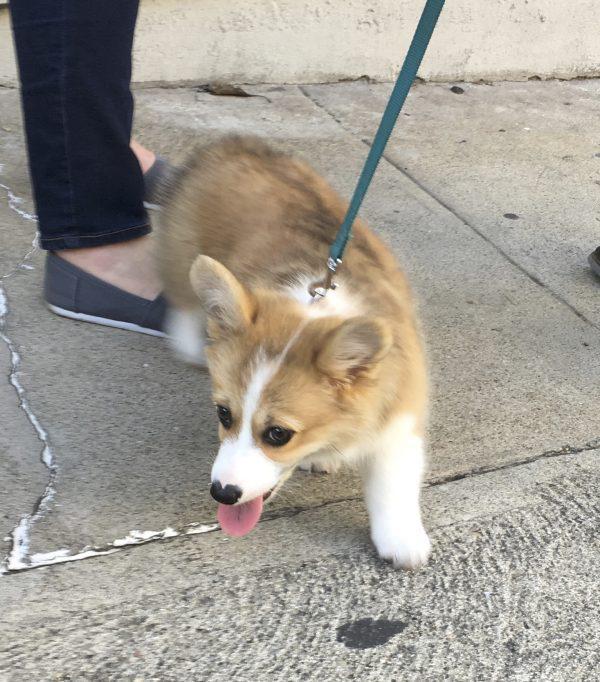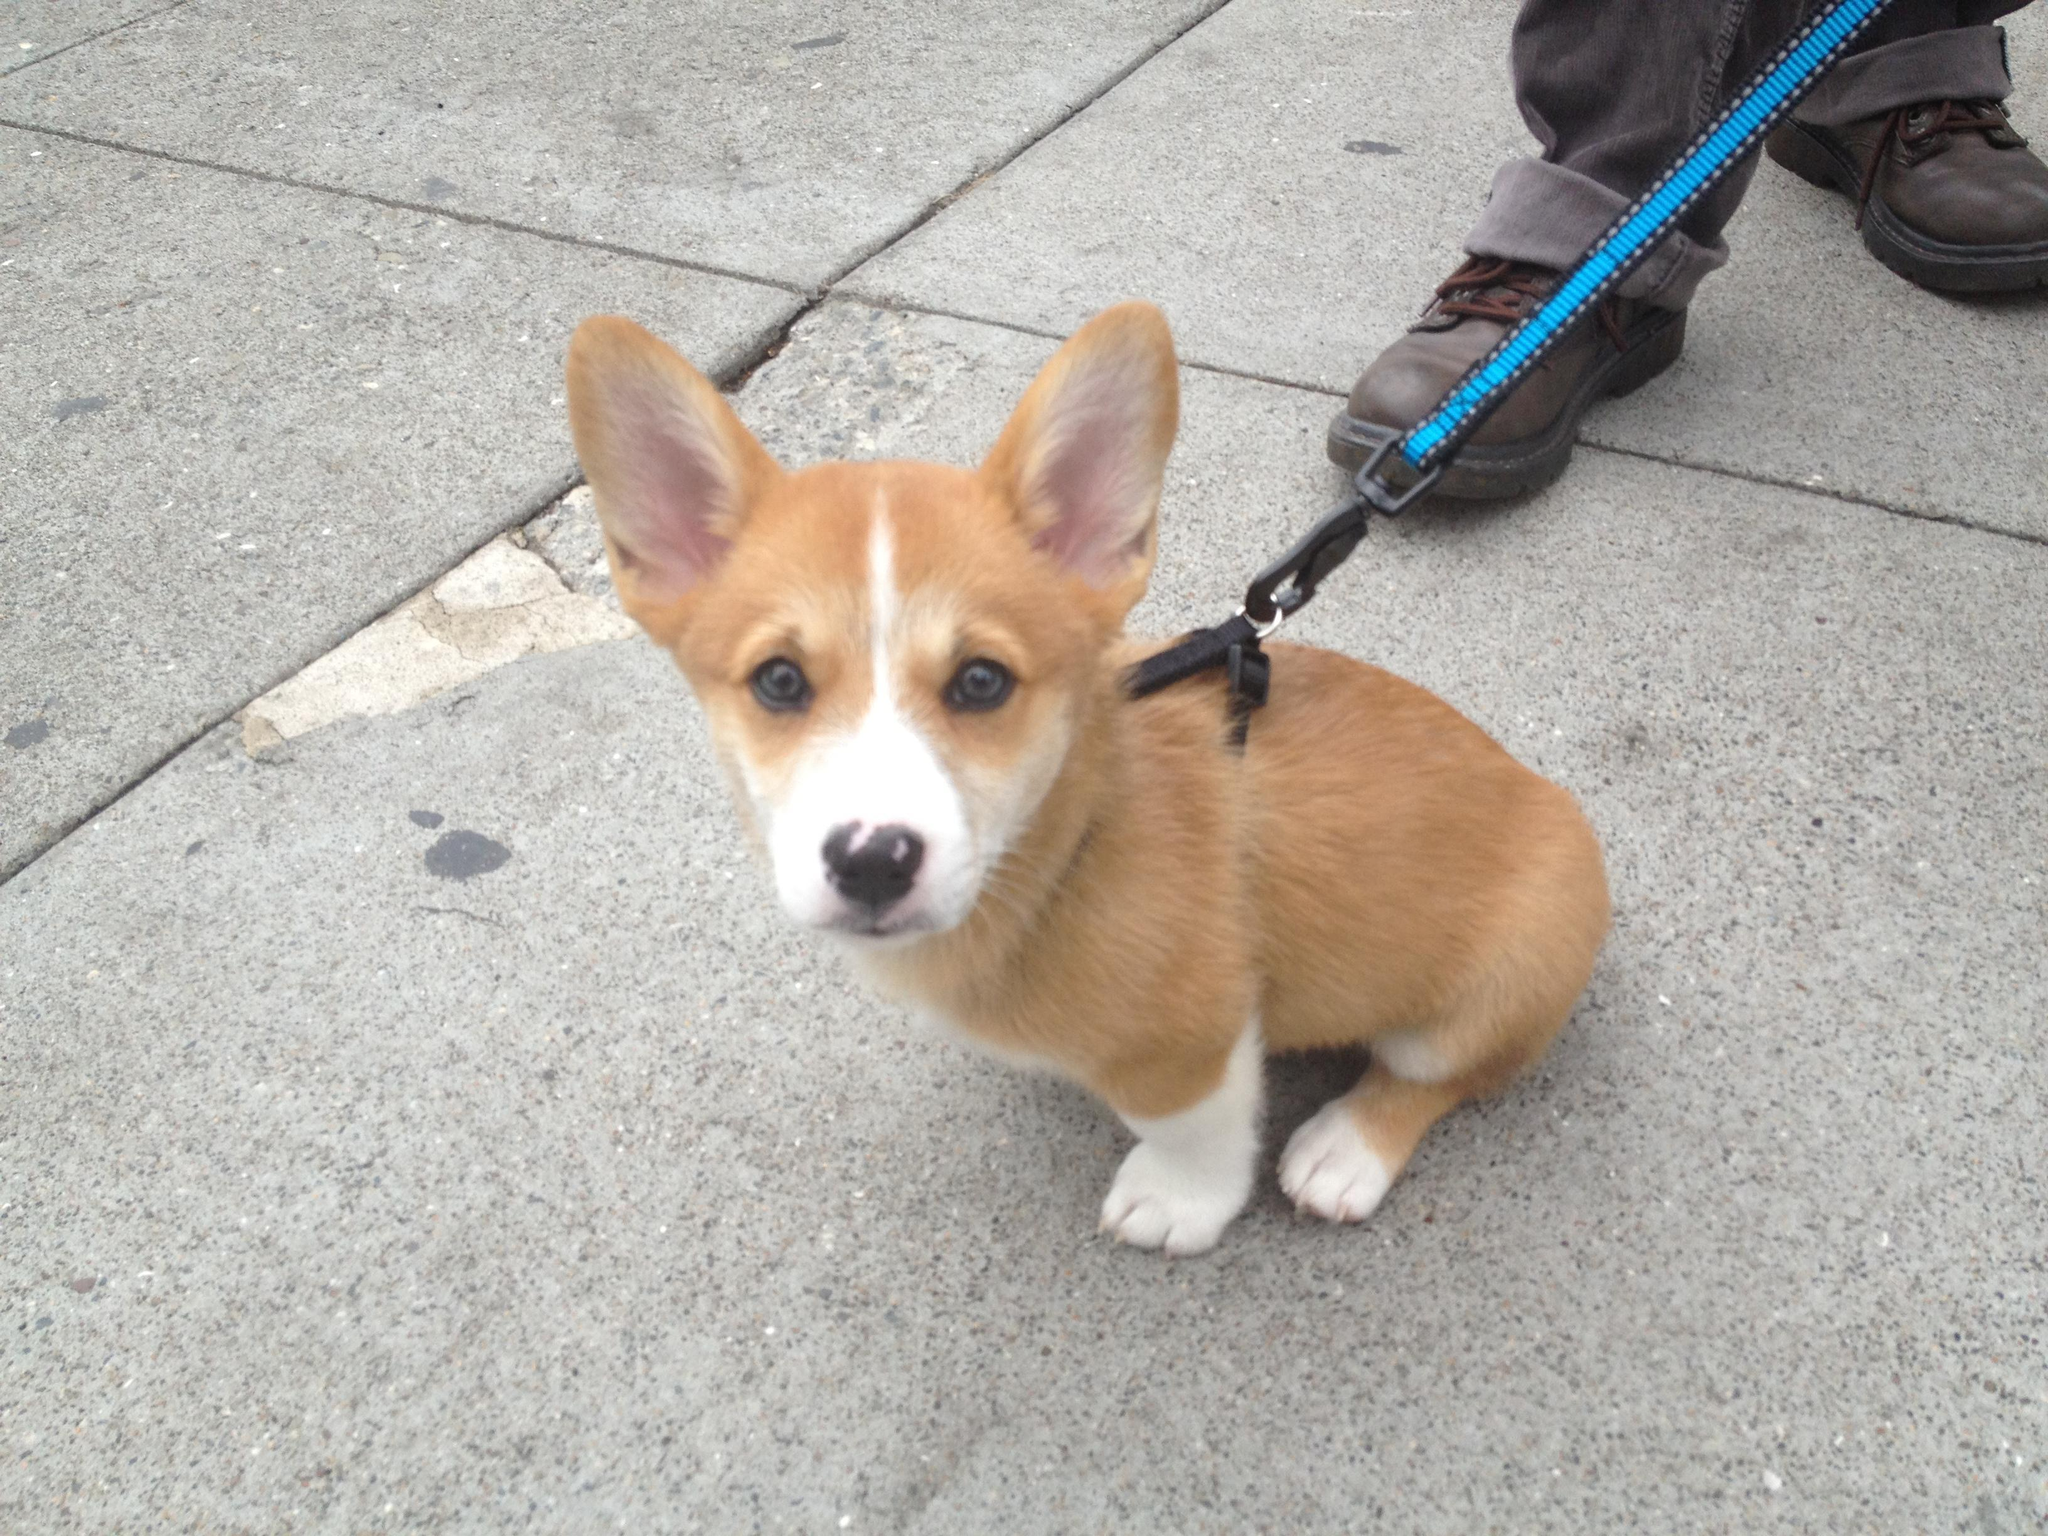The first image is the image on the left, the second image is the image on the right. Considering the images on both sides, is "At least one pup is outside." valid? Answer yes or no. Yes. The first image is the image on the left, the second image is the image on the right. For the images shown, is this caption "At least one puppy is outside." true? Answer yes or no. Yes. 